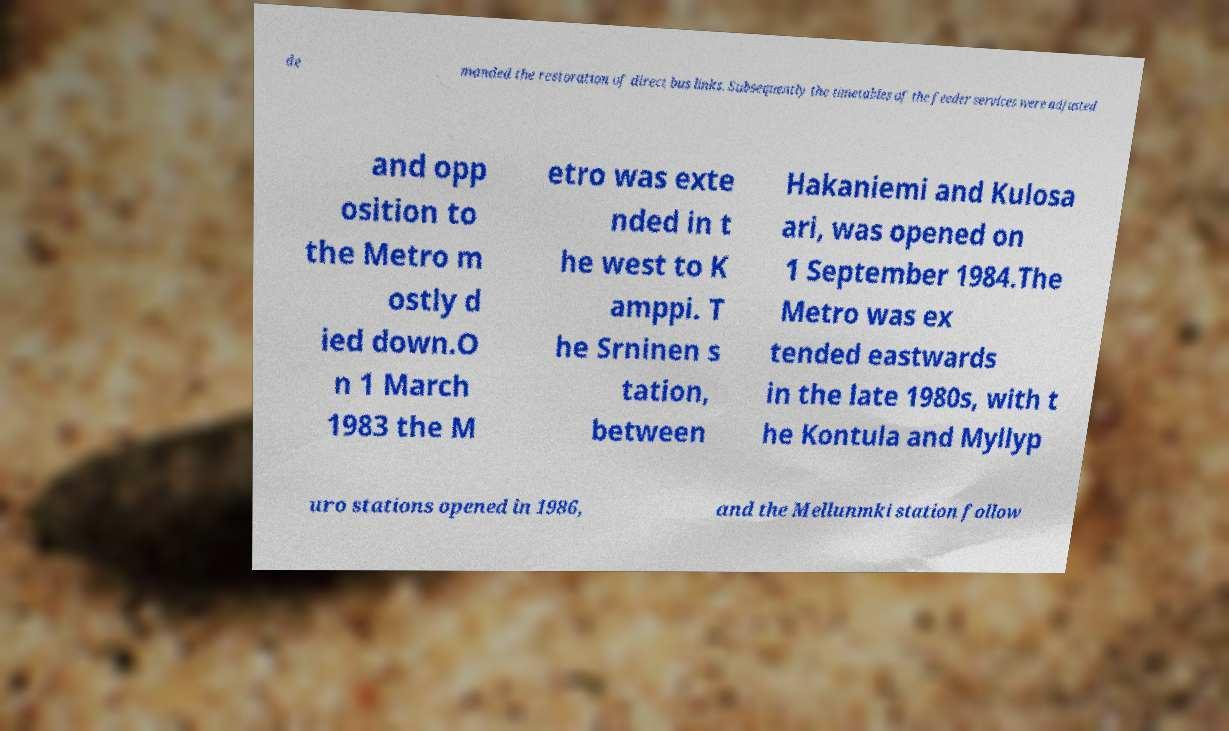I need the written content from this picture converted into text. Can you do that? de manded the restoration of direct bus links. Subsequently the timetables of the feeder services were adjusted and opp osition to the Metro m ostly d ied down.O n 1 March 1983 the M etro was exte nded in t he west to K amppi. T he Srninen s tation, between Hakaniemi and Kulosa ari, was opened on 1 September 1984.The Metro was ex tended eastwards in the late 1980s, with t he Kontula and Myllyp uro stations opened in 1986, and the Mellunmki station follow 